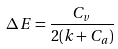<formula> <loc_0><loc_0><loc_500><loc_500>\Delta E = \frac { C _ { v } } { 2 ( k + C _ { a } ) }</formula> 